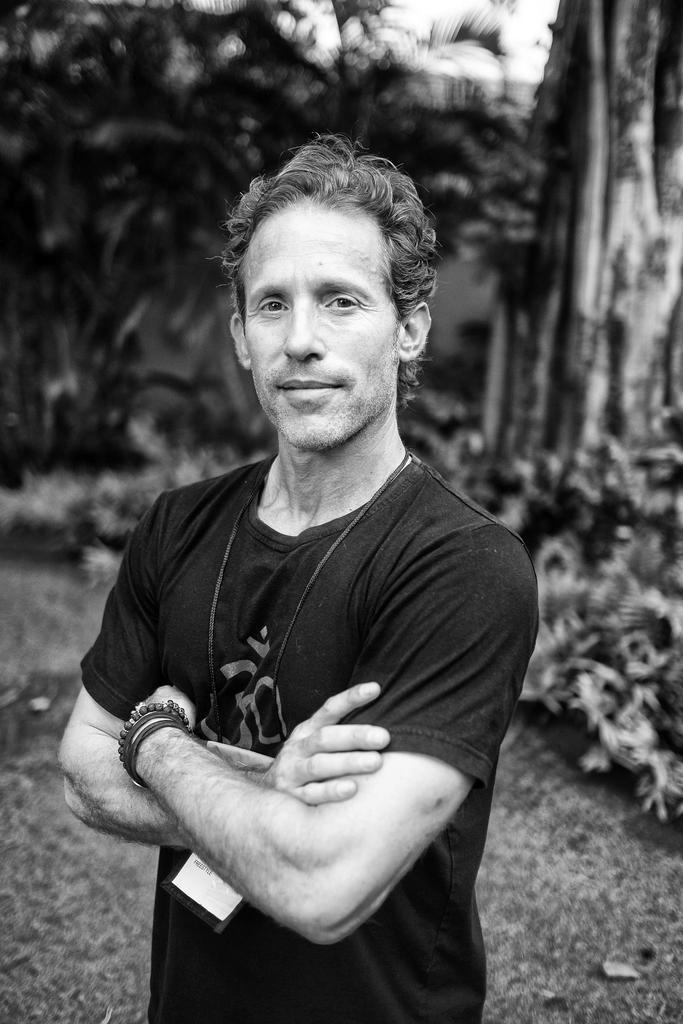In one or two sentences, can you explain what this image depicts? Here we can see black and white image. In the image we can see a man standing, wearing clothes, bracelets, identity card and the man is smiling. Here we can see grass, leaves and the background is blurred. 